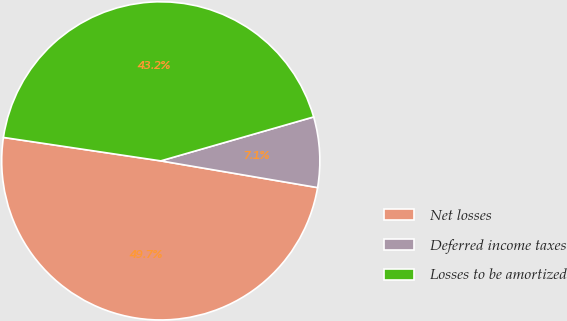Convert chart to OTSL. <chart><loc_0><loc_0><loc_500><loc_500><pie_chart><fcel>Net losses<fcel>Deferred income taxes<fcel>Losses to be amortized<nl><fcel>49.67%<fcel>7.14%<fcel>43.19%<nl></chart> 